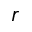<formula> <loc_0><loc_0><loc_500><loc_500>r</formula> 